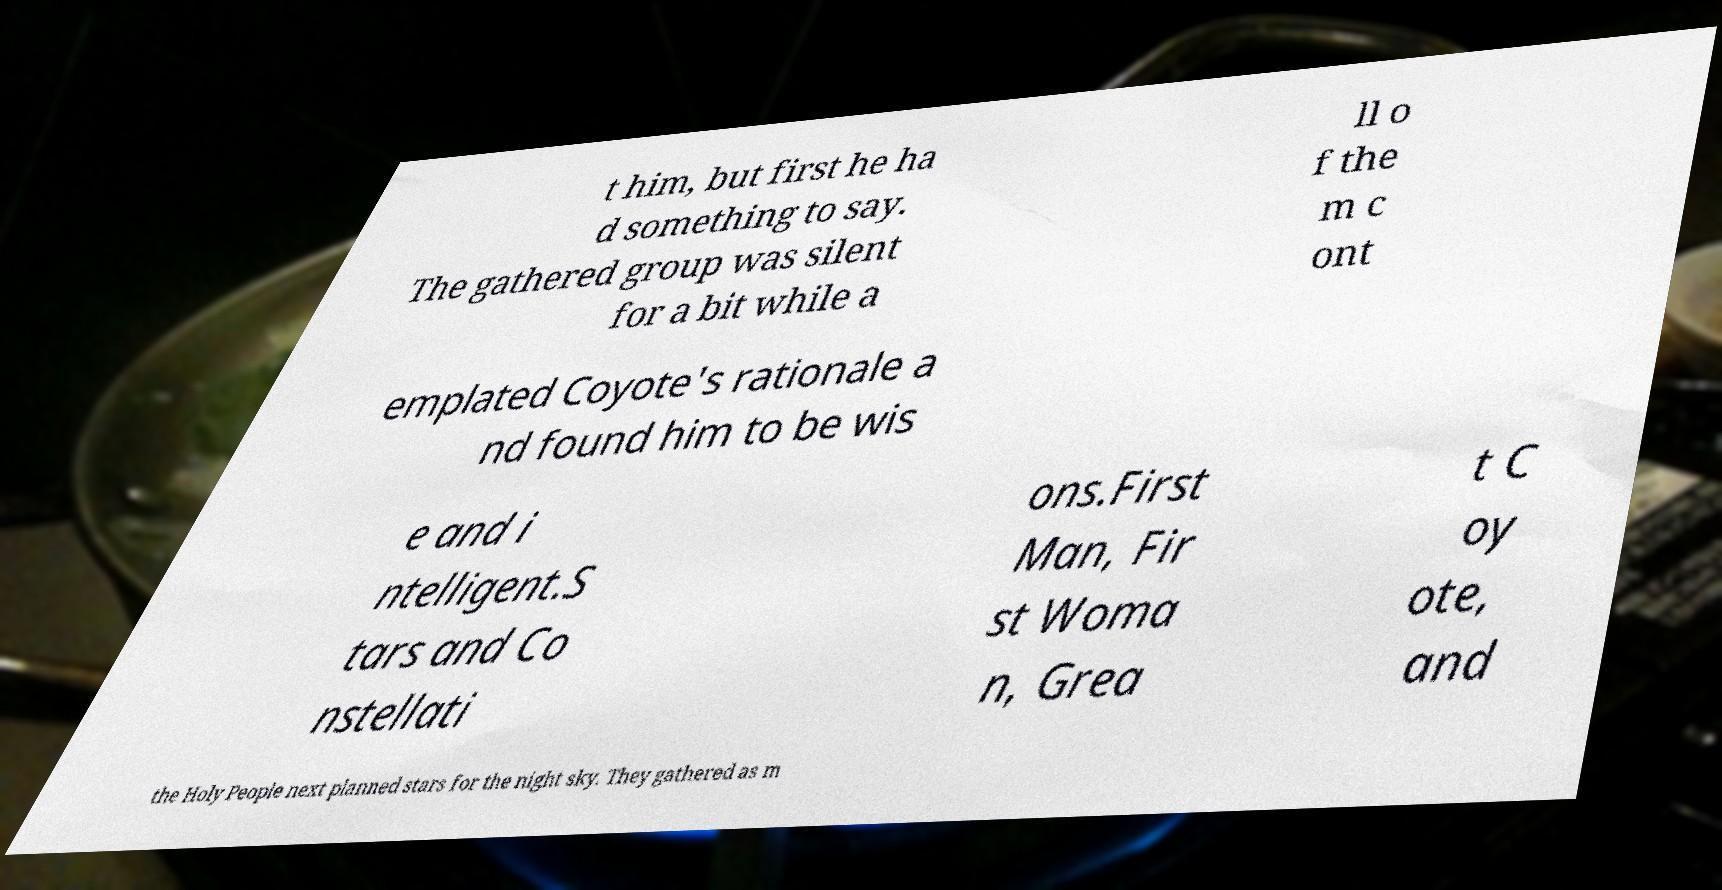Please read and relay the text visible in this image. What does it say? t him, but first he ha d something to say. The gathered group was silent for a bit while a ll o f the m c ont emplated Coyote's rationale a nd found him to be wis e and i ntelligent.S tars and Co nstellati ons.First Man, Fir st Woma n, Grea t C oy ote, and the Holy People next planned stars for the night sky. They gathered as m 